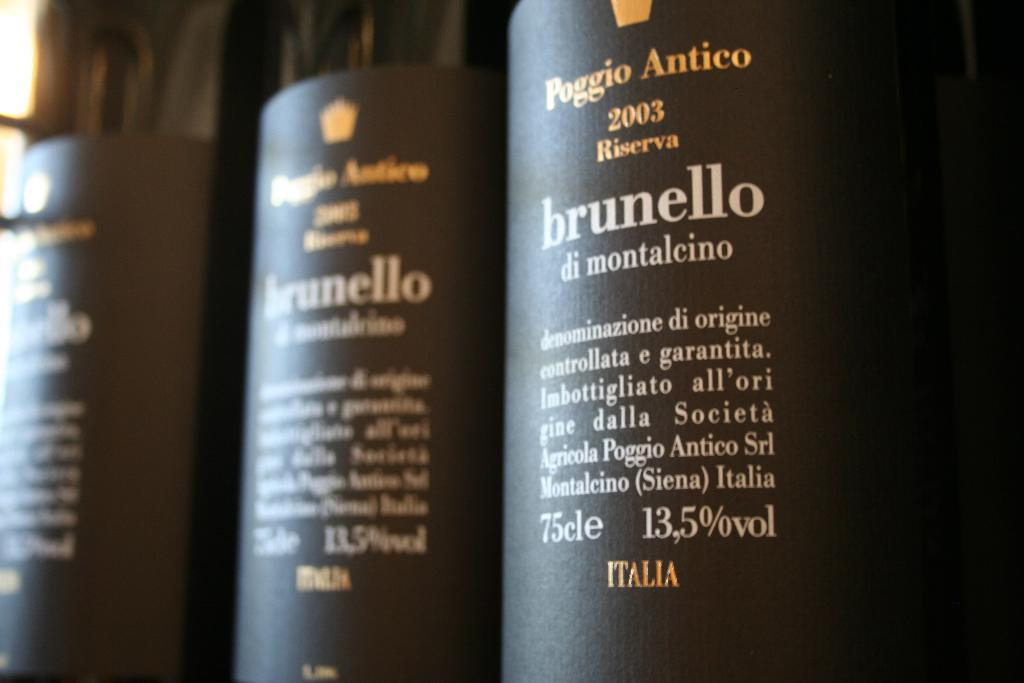How many bottles are visible in the image? There are three bottles in the image. What is unique about each bottle? Each bottle has a sticker on it. Is there a volcano erupting in the background of the image? No, there is no volcano or any indication of an eruption in the image. 